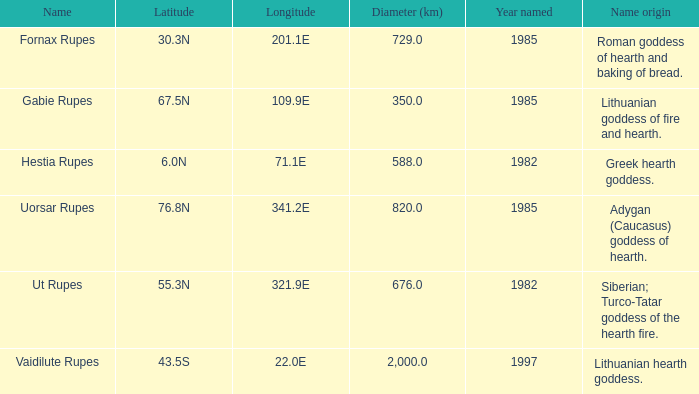At a longitude of 109.9e, how many features were found? 1.0. 